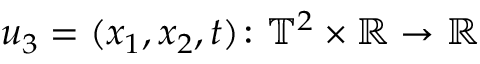<formula> <loc_0><loc_0><loc_500><loc_500>u _ { 3 } = ( x _ { 1 } , x _ { 2 } , t ) \colon { \mathbb { T } } ^ { 2 } \times { \mathbb { R } } \to { \mathbb { R } }</formula> 